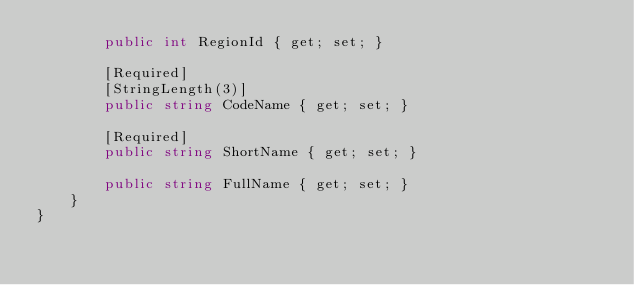Convert code to text. <code><loc_0><loc_0><loc_500><loc_500><_C#_>        public int RegionId { get; set; }

        [Required]
        [StringLength(3)]
        public string CodeName { get; set; }

        [Required]
        public string ShortName { get; set; }

        public string FullName { get; set; }
    }
}
</code> 